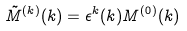Convert formula to latex. <formula><loc_0><loc_0><loc_500><loc_500>\tilde { M } ^ { ( k ) } ( { k } ) = \epsilon ^ { k } ( { k } ) M ^ { ( 0 ) } ( { k } )</formula> 